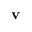<formula> <loc_0><loc_0><loc_500><loc_500>v</formula> 